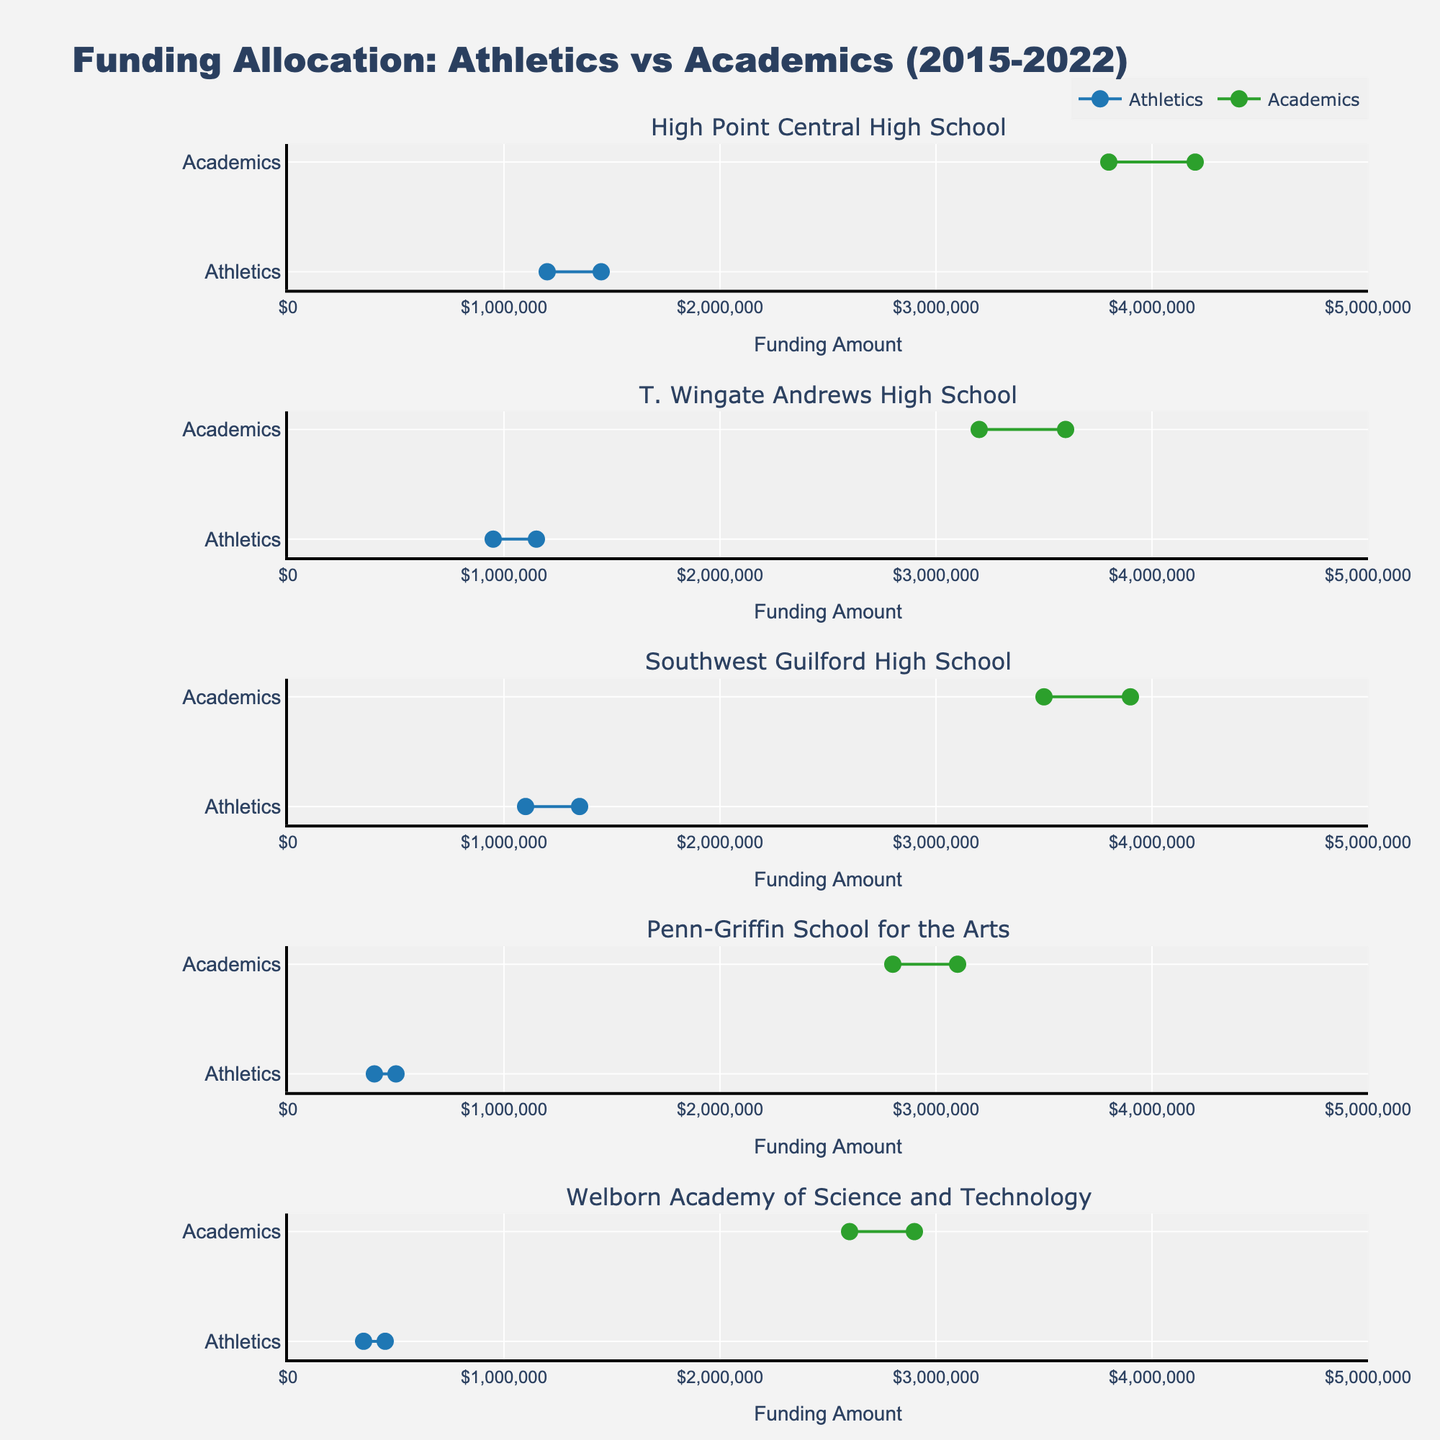What's the title of the figure? The title is displayed at the top of the figure.
Answer: Funding Allocation: Athletics vs Academics (2015-2022) What is the color used to represent Athletics funding? By observing the markers and lines associated with Athletics, we notice they are all the same color.
Answer: Blue How much did High Point Central High School's academic funding increase from 2015 to 2022? Locate High Point Central High School Academics; the funding values for 2015 and 2022 are $3,800,000 and $4,200,000 respectively. The increase is $4,200,000 - $3,800,000.
Answer: $400,000 Which school had the smallest increase in athletics funding? Look at the funding differences for athletics across all schools from 2015 to 2022. Identify the smallest increase among these.
Answer: Penn-Griffin School for the Arts What's the total funding increase for Academics at T. Wingate Andrews High School and Southwest Guilford High School combined? Sum the increases for both schools: $3,600,000 - $3,200,000 for T. Wingate Andrews and $3,900,000 - $3,500,000 for Southwest Guilford.
Answer: $800,000 Which school had the largest difference between Athletics and Academics funding in 2022? Compare the differences between Athletics and Academics funding in 2022 for all schools and identify the largest gap.
Answer: High Point Central High School How did Southwest Guilford High School's athletics funding change from 2015 to 2022? Observe Southwest Guilford High School Athletics and note the funding in 2015 and 2022. Calculate the difference.
Answer: Increased by $250,000 What's the average funding for academics across all schools in 2022? Sum the 2022 academic funding for all schools and divide by the number of schools.
Answer: $3,460,000 Which program at Welborn Academy of Science and Technology saw a greater relative increase in funding, Athletics or Academics? Calculate the percentage increase for both programs: Athletics (450,000 - 350,000) / 350,000 and Academics (2,900,000 - 2,600,000) / 2,600,000. Compare these percentages.
Answer: Athletics How much more funding did High Point Central High School Athletics receive in 2022 compared to T. Wingate Andrews High School Athletics? Subtract T. Wingate Andrews Athletics funding in 2022 from High Point Central Athletics funding in 2022.
Answer: $300,000 